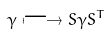<formula> <loc_0><loc_0><loc_500><loc_500>\gamma \longmapsto S \gamma S ^ { T }</formula> 